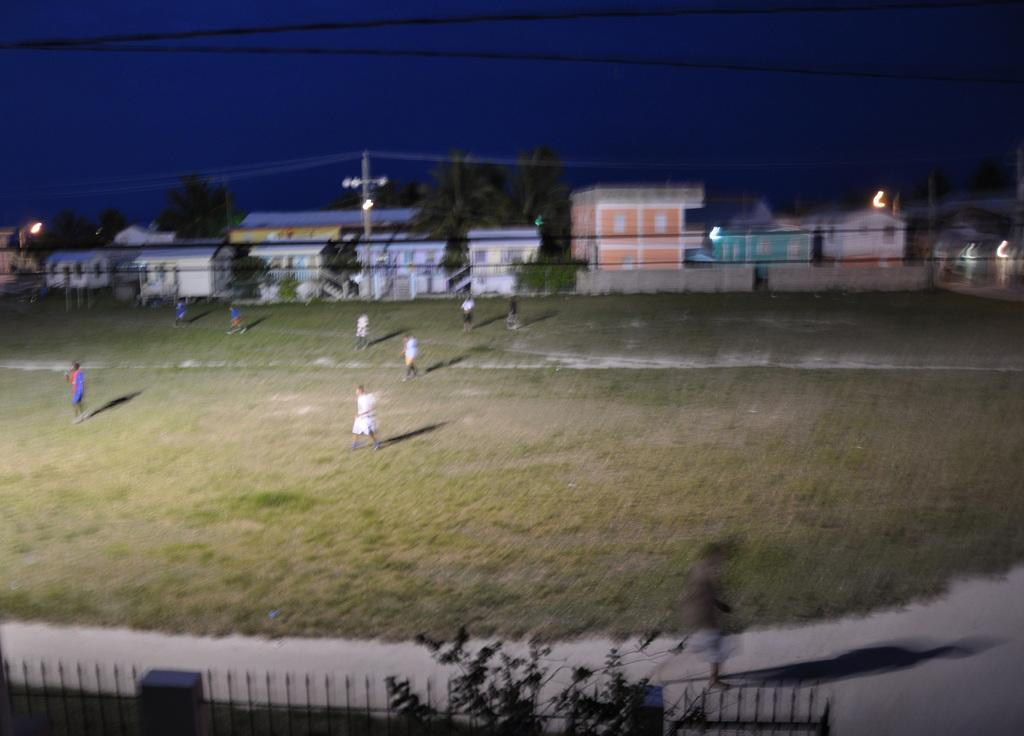How many people are in the image? There is a group of people in the image. What is the position of the people in the image? The people are standing on the ground. What can be seen in the background of the image? There are buildings, trees, and the sky visible in the background of the image. What are the people writing on the ground in the image? There is no indication in the image that the people are writing on the ground. 